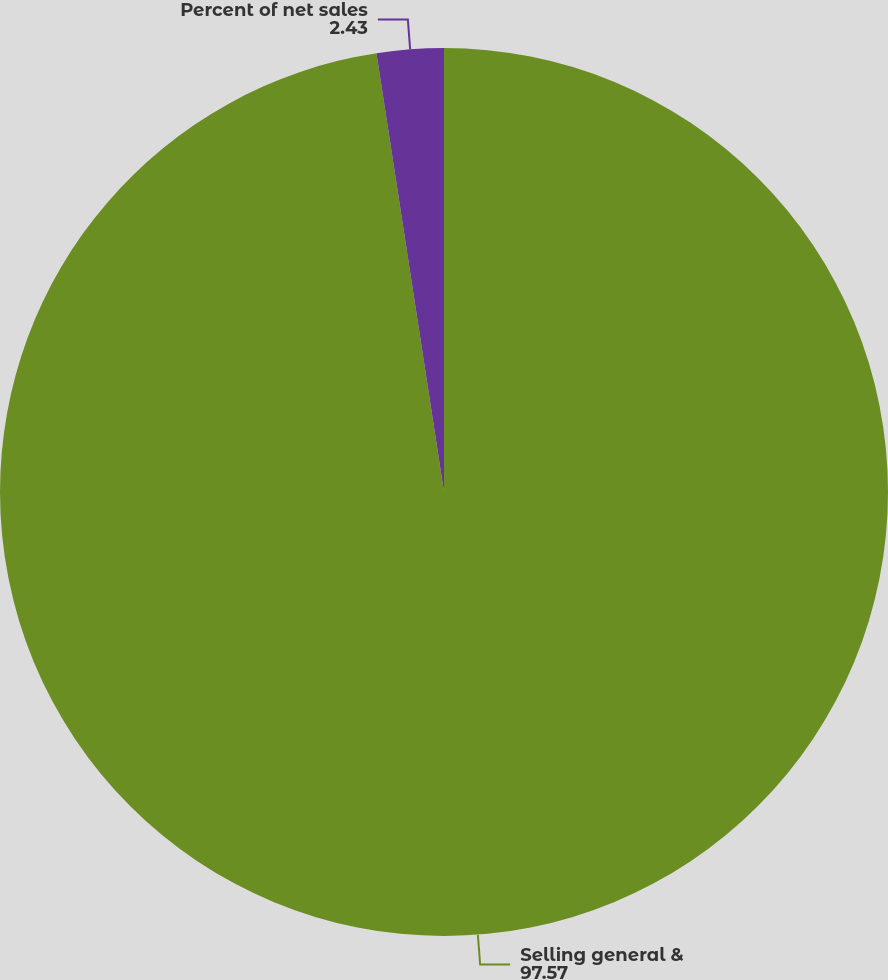Convert chart. <chart><loc_0><loc_0><loc_500><loc_500><pie_chart><fcel>Selling general &<fcel>Percent of net sales<nl><fcel>97.57%<fcel>2.43%<nl></chart> 